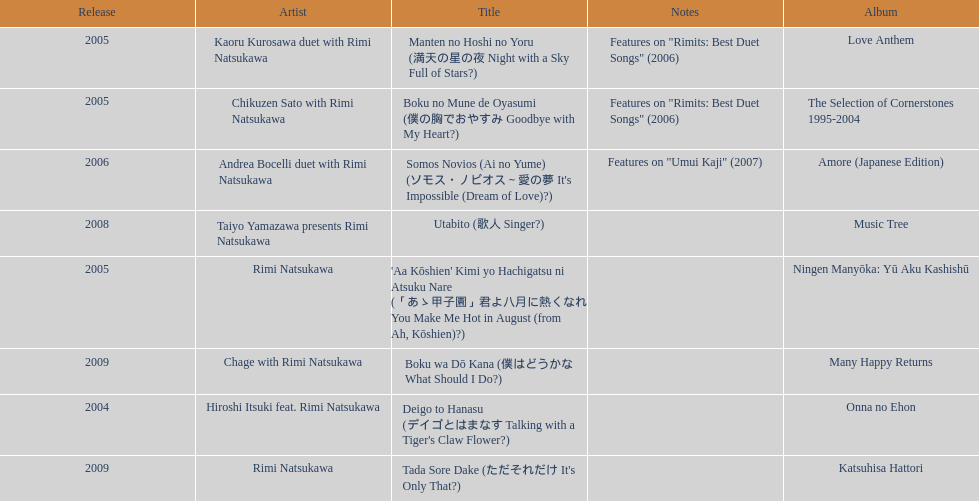What song was this artist on after utabito? Boku wa Dō Kana. 